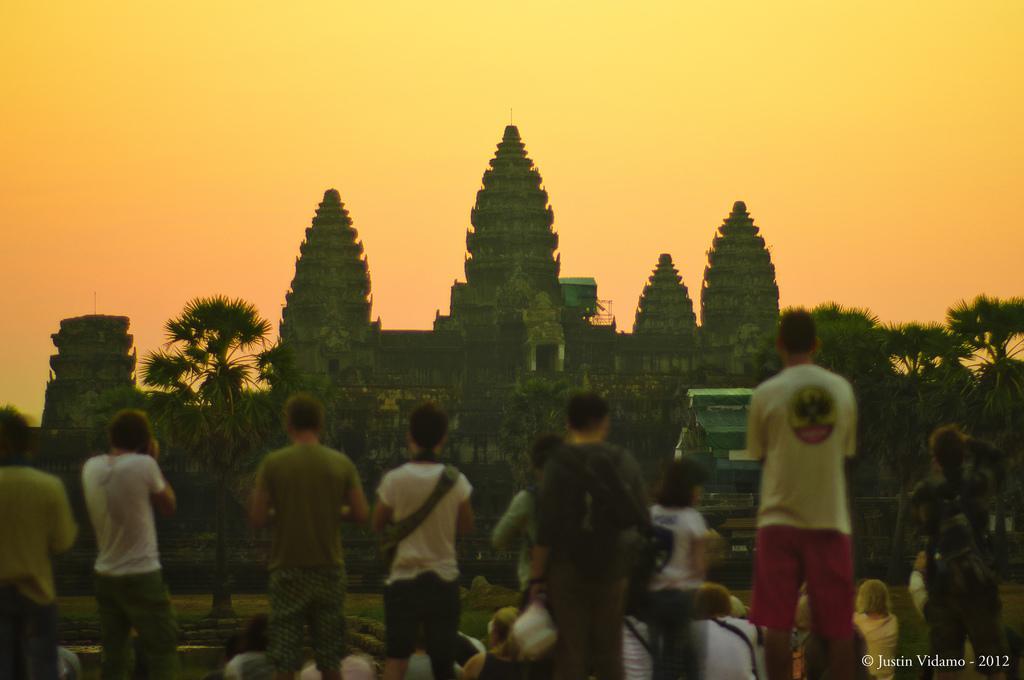Describe this image in one or two sentences. On the bottom left, there is a watermark. In the background, there are persons, trees, buildings and grass on the ground and there are clouds in the sky. 